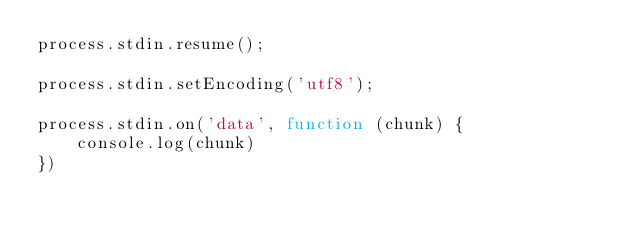<code> <loc_0><loc_0><loc_500><loc_500><_JavaScript_>process.stdin.resume();

process.stdin.setEncoding('utf8');

process.stdin.on('data', function (chunk) {
    console.log(chunk)
})</code> 